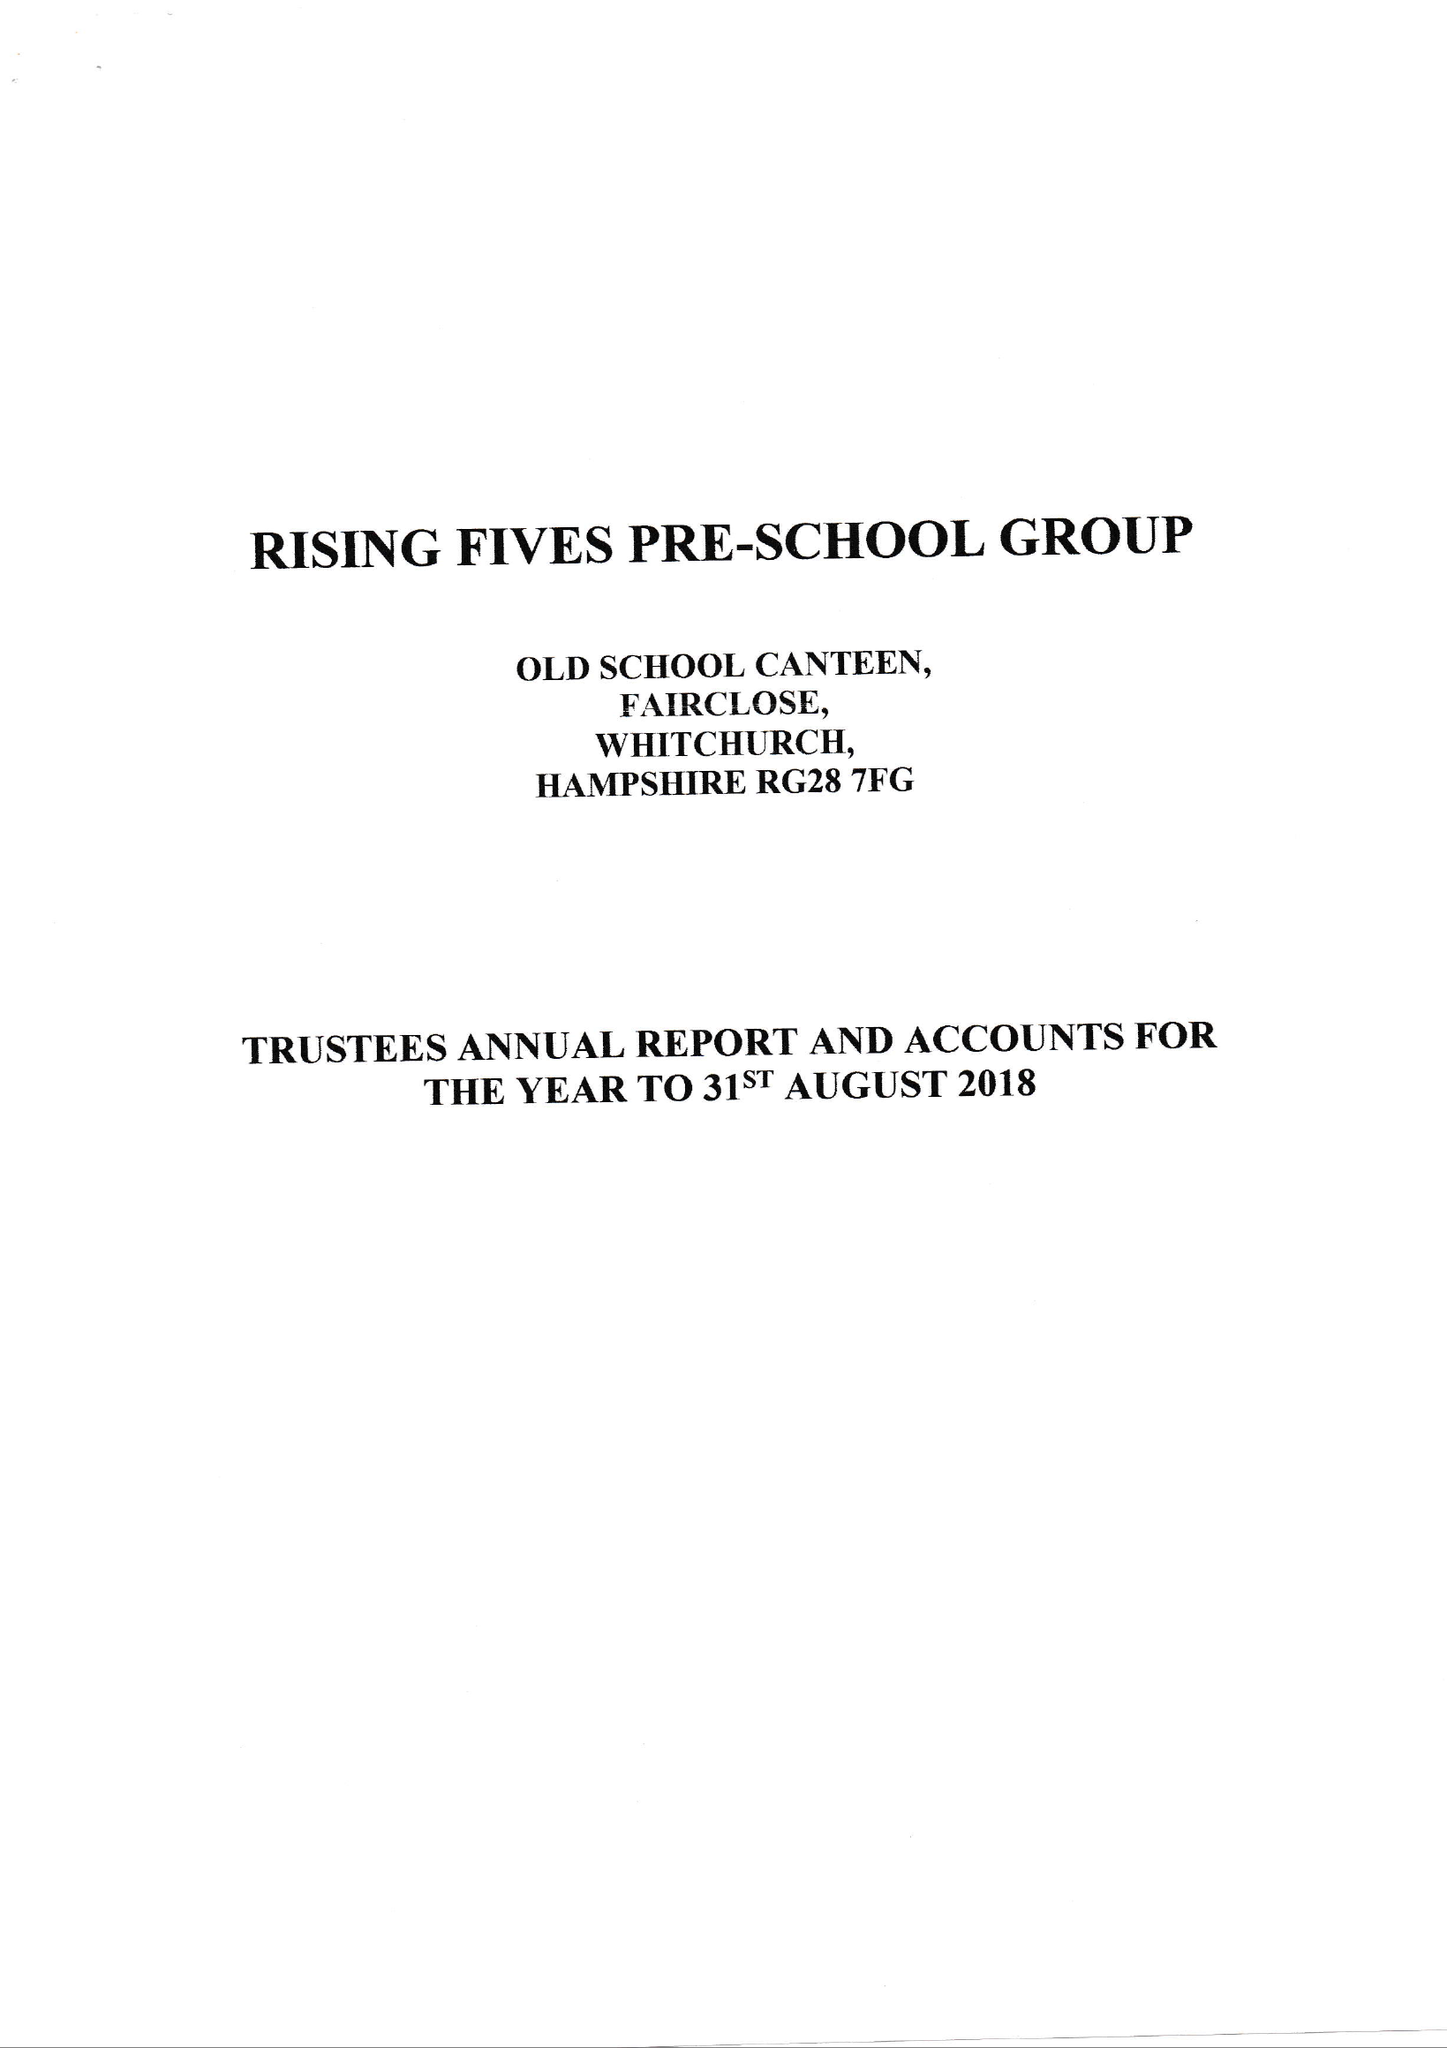What is the value for the charity_name?
Answer the question using a single word or phrase. Rising Fives Pre-School Group 